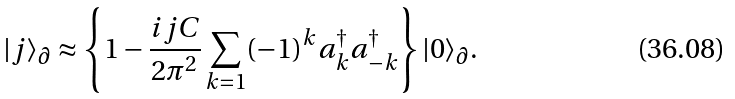<formula> <loc_0><loc_0><loc_500><loc_500>| j \rangle _ { \partial } \approx \left \{ 1 - \frac { i j C } { 2 \pi ^ { 2 } } \sum _ { k = 1 } ( - 1 ) ^ { k } a ^ { \dagger } _ { k } a ^ { \dagger } _ { - k } \right \} | 0 \rangle _ { \partial } .</formula> 